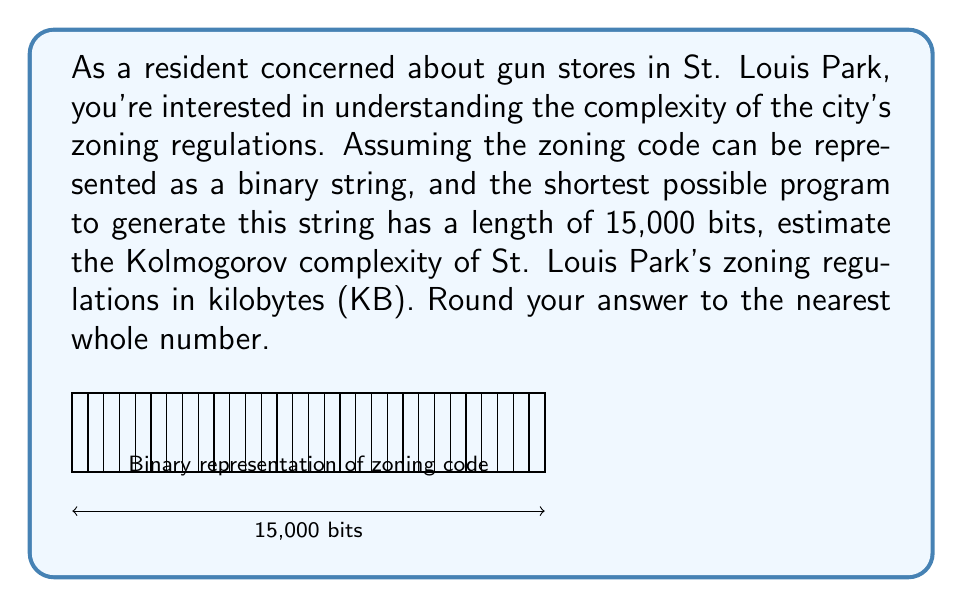Provide a solution to this math problem. To solve this problem, we'll follow these steps:

1) First, recall that Kolmogorov complexity is defined as the length of the shortest possible program that can generate a given string. In this case, we're told that the shortest program to generate St. Louis Park's zoning regulations is 15,000 bits long.

2) The Kolmogorov complexity is therefore 15,000 bits.

3) We need to convert this to kilobytes (KB). Let's start by converting bits to bytes:
   
   $$ \text{Bytes} = \frac{\text{Bits}}{8} $$
   
   $$ \text{Bytes} = \frac{15,000}{8} = 1,875 \text{ bytes} $$

4) Now, let's convert bytes to kilobytes:
   
   $$ \text{KB} = \frac{\text{Bytes}}{1024} $$
   
   $$ \text{KB} = \frac{1,875}{1024} \approx 1.83105 \text{ KB} $$

5) Rounding to the nearest whole number:
   
   $$ 1.83105 \text{ KB} \approx 2 \text{ KB} $$

Therefore, the estimated Kolmogorov complexity of St. Louis Park's zoning regulations is approximately 2 KB.
Answer: 2 KB 